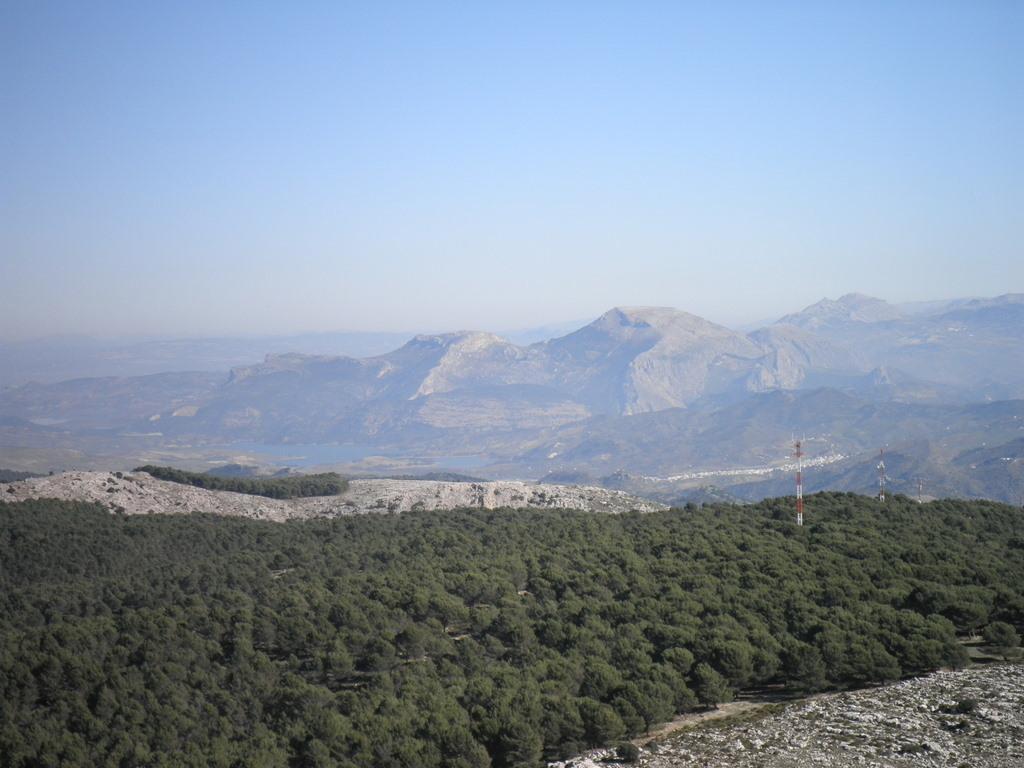Please provide a concise description of this image. In the picture it is a beautiful scenery with many plants and huge mountains. 